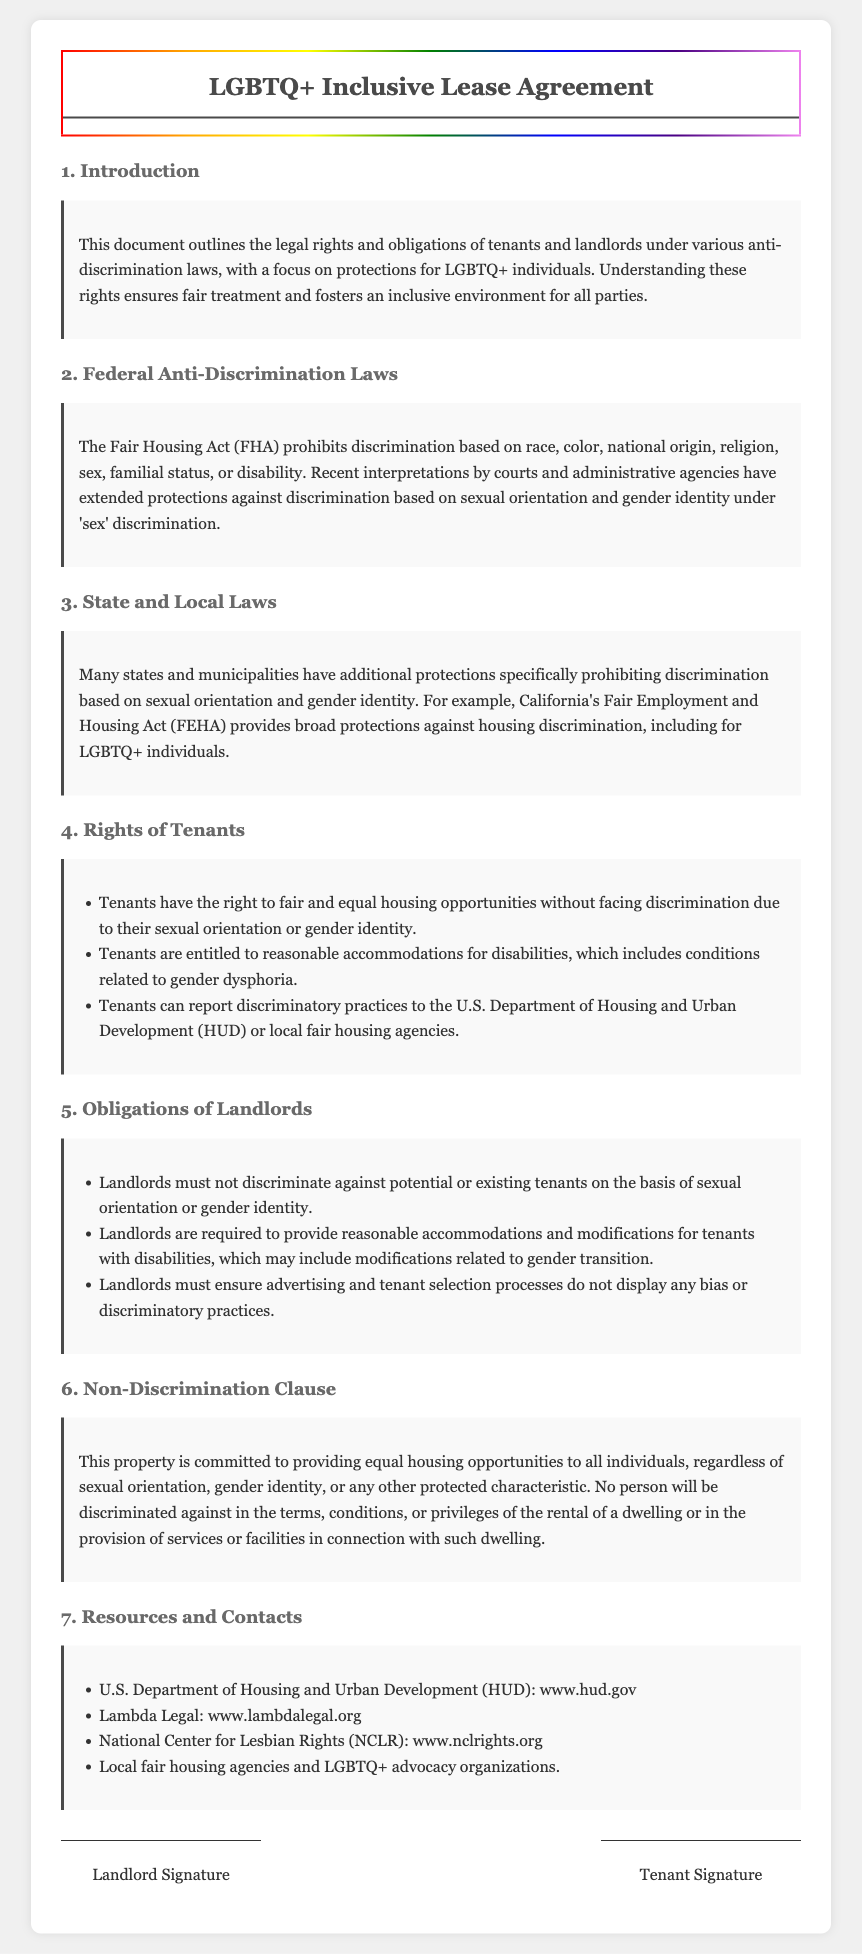what is the title of the document? The title is found at the top of the document, identified as the heading.
Answer: LGBTQ+ Inclusive Lease Agreement what law prohibits discrimination based on sexual orientation? The law is mentioned under the Federal Anti-Discrimination Laws section of the document.
Answer: Fair Housing Act which state has additional protections for LGBTQ+ individuals? The state is specifically called out in the State and Local Laws section as providing broad protections.
Answer: California what are tenants entitled to regarding disabilities? This is outlined in the Rights of Tenants section, referring to specific accommodations.
Answer: Reasonable accommodations what must landlords not do regarding tenant selection? The document specifies required actions under the Obligations of Landlords section related to tenant selection practices.
Answer: Discriminate who can tenants report discriminatory practices to? This information is provided in the Rights of Tenants section for addressing issues of discrimination.
Answer: U.S. Department of Housing and Urban Development what is a key commitment in the Non-Discrimination Clause? The key commitment is outlined in the section title and reflects the core purpose of this clause.
Answer: Equal housing opportunities how can tenants find more information or assistance? This is presented in the Resources and Contacts section, detailing where to seek help or further information.
Answer: Local fair housing agencies and LGBTQ+ advocacy organizations what is required from landlords regarding modifications for tenants with disabilities? This obligation, specified in the Obligations of Landlords section, addresses particular needs linked to disabilities.
Answer: Provide reasonable accommodations and modifications 